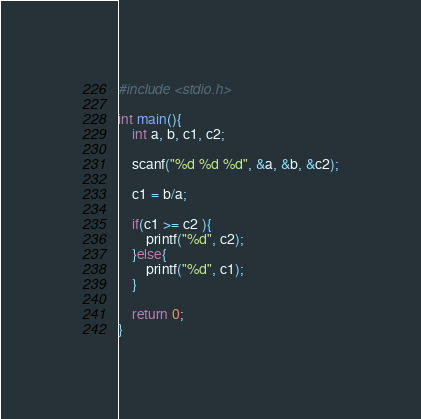Convert code to text. <code><loc_0><loc_0><loc_500><loc_500><_C_>#include <stdio.h>

int main(){
	int a, b, c1, c2;
  	
  	scanf("%d %d %d", &a, &b, &c2);
  
  	c1 = b/a;
  
  	if(c1 >= c2 ){
  		printf("%d", c2);
    }else{
    	printf("%d", c1);
    }
  
  	return 0;
}</code> 